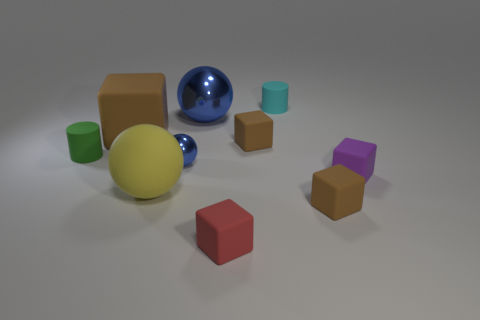The large yellow rubber object is what shape?
Provide a succinct answer. Sphere. Is there any other thing of the same color as the tiny metallic ball?
Give a very brief answer. Yes. Does the matte thing that is to the left of the large brown rubber cube have the same size as the brown thing left of the small red block?
Offer a very short reply. No. The brown rubber object in front of the small matte cylinder to the left of the large brown thing is what shape?
Your answer should be compact. Cube. There is a red matte block; does it have the same size as the shiny object behind the big brown cube?
Your answer should be compact. No. There is a rubber block that is in front of the tiny brown thing that is on the right side of the small cyan thing on the right side of the big blue shiny ball; what is its size?
Make the answer very short. Small. How many things are either small cubes that are behind the red rubber cube or small metallic balls?
Give a very brief answer. 4. How many blue metallic spheres are behind the large matte object in front of the green cylinder?
Ensure brevity in your answer.  2. Is the number of yellow spheres in front of the small cyan cylinder greater than the number of small purple cubes?
Your answer should be very brief. No. What size is the rubber cube that is both to the left of the cyan rubber thing and in front of the green rubber thing?
Ensure brevity in your answer.  Small. 